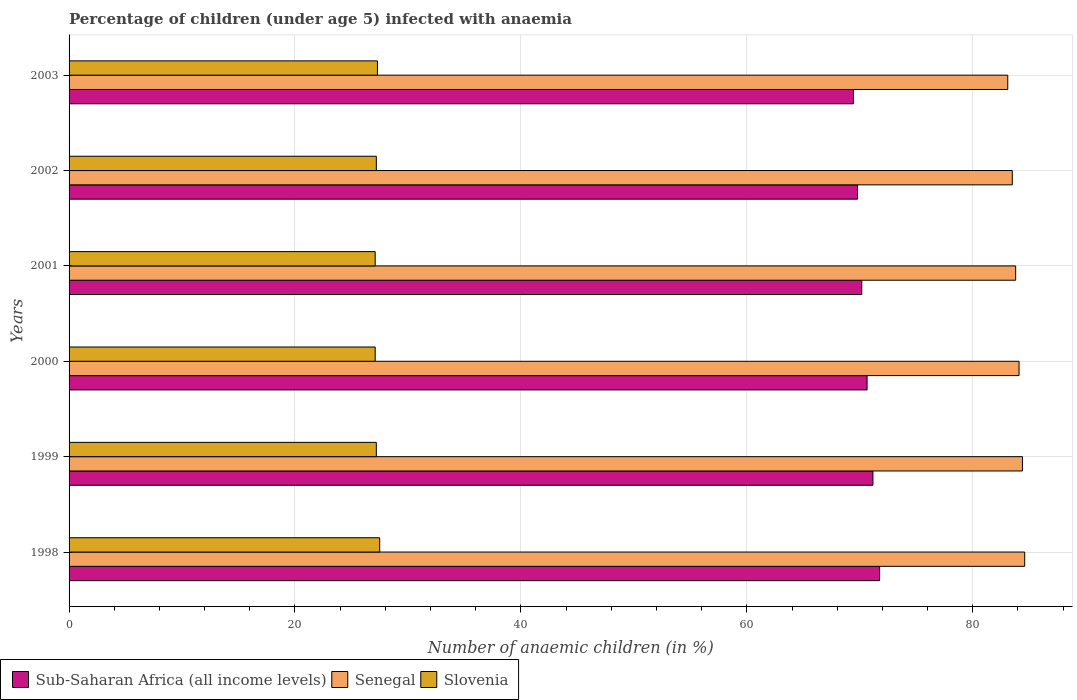Are the number of bars on each tick of the Y-axis equal?
Provide a short and direct response. Yes. How many bars are there on the 3rd tick from the top?
Your answer should be very brief. 3. What is the label of the 2nd group of bars from the top?
Give a very brief answer. 2002. Across all years, what is the maximum percentage of children infected with anaemia in in Senegal?
Offer a very short reply. 84.6. Across all years, what is the minimum percentage of children infected with anaemia in in Slovenia?
Offer a terse response. 27.1. In which year was the percentage of children infected with anaemia in in Slovenia maximum?
Provide a short and direct response. 1998. What is the total percentage of children infected with anaemia in in Senegal in the graph?
Provide a short and direct response. 503.5. What is the difference between the percentage of children infected with anaemia in in Sub-Saharan Africa (all income levels) in 2000 and that in 2001?
Your answer should be very brief. 0.47. What is the difference between the percentage of children infected with anaemia in in Senegal in 2000 and the percentage of children infected with anaemia in in Sub-Saharan Africa (all income levels) in 2003?
Give a very brief answer. 14.66. What is the average percentage of children infected with anaemia in in Slovenia per year?
Ensure brevity in your answer.  27.23. In the year 1999, what is the difference between the percentage of children infected with anaemia in in Senegal and percentage of children infected with anaemia in in Slovenia?
Ensure brevity in your answer.  57.2. What is the ratio of the percentage of children infected with anaemia in in Senegal in 1999 to that in 2001?
Make the answer very short. 1.01. Is the difference between the percentage of children infected with anaemia in in Senegal in 2001 and 2002 greater than the difference between the percentage of children infected with anaemia in in Slovenia in 2001 and 2002?
Offer a terse response. Yes. What is the difference between the highest and the second highest percentage of children infected with anaemia in in Sub-Saharan Africa (all income levels)?
Your answer should be very brief. 0.59. What is the difference between the highest and the lowest percentage of children infected with anaemia in in Senegal?
Make the answer very short. 1.5. In how many years, is the percentage of children infected with anaemia in in Slovenia greater than the average percentage of children infected with anaemia in in Slovenia taken over all years?
Offer a terse response. 2. What does the 1st bar from the top in 2002 represents?
Keep it short and to the point. Slovenia. What does the 3rd bar from the bottom in 1999 represents?
Your answer should be compact. Slovenia. Is it the case that in every year, the sum of the percentage of children infected with anaemia in in Senegal and percentage of children infected with anaemia in in Slovenia is greater than the percentage of children infected with anaemia in in Sub-Saharan Africa (all income levels)?
Offer a terse response. Yes. Are all the bars in the graph horizontal?
Ensure brevity in your answer.  Yes. Are the values on the major ticks of X-axis written in scientific E-notation?
Your answer should be compact. No. Where does the legend appear in the graph?
Give a very brief answer. Bottom left. How many legend labels are there?
Ensure brevity in your answer.  3. How are the legend labels stacked?
Your answer should be compact. Horizontal. What is the title of the graph?
Offer a very short reply. Percentage of children (under age 5) infected with anaemia. Does "Micronesia" appear as one of the legend labels in the graph?
Offer a very short reply. No. What is the label or title of the X-axis?
Keep it short and to the point. Number of anaemic children (in %). What is the label or title of the Y-axis?
Make the answer very short. Years. What is the Number of anaemic children (in %) of Sub-Saharan Africa (all income levels) in 1998?
Your answer should be very brief. 71.75. What is the Number of anaemic children (in %) in Senegal in 1998?
Provide a succinct answer. 84.6. What is the Number of anaemic children (in %) of Slovenia in 1998?
Offer a very short reply. 27.5. What is the Number of anaemic children (in %) in Sub-Saharan Africa (all income levels) in 1999?
Offer a very short reply. 71.16. What is the Number of anaemic children (in %) of Senegal in 1999?
Offer a very short reply. 84.4. What is the Number of anaemic children (in %) in Slovenia in 1999?
Give a very brief answer. 27.2. What is the Number of anaemic children (in %) of Sub-Saharan Africa (all income levels) in 2000?
Offer a terse response. 70.65. What is the Number of anaemic children (in %) of Senegal in 2000?
Your answer should be compact. 84.1. What is the Number of anaemic children (in %) in Slovenia in 2000?
Your response must be concise. 27.1. What is the Number of anaemic children (in %) in Sub-Saharan Africa (all income levels) in 2001?
Offer a very short reply. 70.17. What is the Number of anaemic children (in %) of Senegal in 2001?
Your answer should be compact. 83.8. What is the Number of anaemic children (in %) of Slovenia in 2001?
Provide a succinct answer. 27.1. What is the Number of anaemic children (in %) of Sub-Saharan Africa (all income levels) in 2002?
Provide a succinct answer. 69.8. What is the Number of anaemic children (in %) in Senegal in 2002?
Offer a terse response. 83.5. What is the Number of anaemic children (in %) in Slovenia in 2002?
Give a very brief answer. 27.2. What is the Number of anaemic children (in %) in Sub-Saharan Africa (all income levels) in 2003?
Your answer should be very brief. 69.44. What is the Number of anaemic children (in %) of Senegal in 2003?
Offer a very short reply. 83.1. What is the Number of anaemic children (in %) in Slovenia in 2003?
Offer a very short reply. 27.3. Across all years, what is the maximum Number of anaemic children (in %) in Sub-Saharan Africa (all income levels)?
Your response must be concise. 71.75. Across all years, what is the maximum Number of anaemic children (in %) of Senegal?
Your response must be concise. 84.6. Across all years, what is the maximum Number of anaemic children (in %) of Slovenia?
Offer a very short reply. 27.5. Across all years, what is the minimum Number of anaemic children (in %) of Sub-Saharan Africa (all income levels)?
Your answer should be very brief. 69.44. Across all years, what is the minimum Number of anaemic children (in %) of Senegal?
Keep it short and to the point. 83.1. Across all years, what is the minimum Number of anaemic children (in %) in Slovenia?
Make the answer very short. 27.1. What is the total Number of anaemic children (in %) in Sub-Saharan Africa (all income levels) in the graph?
Offer a terse response. 422.98. What is the total Number of anaemic children (in %) of Senegal in the graph?
Keep it short and to the point. 503.5. What is the total Number of anaemic children (in %) of Slovenia in the graph?
Provide a short and direct response. 163.4. What is the difference between the Number of anaemic children (in %) of Sub-Saharan Africa (all income levels) in 1998 and that in 1999?
Your response must be concise. 0.59. What is the difference between the Number of anaemic children (in %) of Senegal in 1998 and that in 1999?
Ensure brevity in your answer.  0.2. What is the difference between the Number of anaemic children (in %) in Sub-Saharan Africa (all income levels) in 1998 and that in 2000?
Provide a short and direct response. 1.11. What is the difference between the Number of anaemic children (in %) of Senegal in 1998 and that in 2000?
Your response must be concise. 0.5. What is the difference between the Number of anaemic children (in %) in Sub-Saharan Africa (all income levels) in 1998 and that in 2001?
Offer a terse response. 1.58. What is the difference between the Number of anaemic children (in %) in Sub-Saharan Africa (all income levels) in 1998 and that in 2002?
Keep it short and to the point. 1.95. What is the difference between the Number of anaemic children (in %) of Sub-Saharan Africa (all income levels) in 1998 and that in 2003?
Keep it short and to the point. 2.32. What is the difference between the Number of anaemic children (in %) in Slovenia in 1998 and that in 2003?
Your answer should be very brief. 0.2. What is the difference between the Number of anaemic children (in %) of Sub-Saharan Africa (all income levels) in 1999 and that in 2000?
Make the answer very short. 0.52. What is the difference between the Number of anaemic children (in %) of Senegal in 1999 and that in 2000?
Your answer should be compact. 0.3. What is the difference between the Number of anaemic children (in %) of Sub-Saharan Africa (all income levels) in 1999 and that in 2001?
Offer a very short reply. 0.99. What is the difference between the Number of anaemic children (in %) in Sub-Saharan Africa (all income levels) in 1999 and that in 2002?
Provide a succinct answer. 1.36. What is the difference between the Number of anaemic children (in %) of Sub-Saharan Africa (all income levels) in 1999 and that in 2003?
Make the answer very short. 1.72. What is the difference between the Number of anaemic children (in %) of Senegal in 1999 and that in 2003?
Make the answer very short. 1.3. What is the difference between the Number of anaemic children (in %) of Slovenia in 1999 and that in 2003?
Offer a very short reply. -0.1. What is the difference between the Number of anaemic children (in %) in Sub-Saharan Africa (all income levels) in 2000 and that in 2001?
Provide a short and direct response. 0.47. What is the difference between the Number of anaemic children (in %) of Senegal in 2000 and that in 2001?
Your response must be concise. 0.3. What is the difference between the Number of anaemic children (in %) of Slovenia in 2000 and that in 2001?
Give a very brief answer. 0. What is the difference between the Number of anaemic children (in %) in Sub-Saharan Africa (all income levels) in 2000 and that in 2002?
Your response must be concise. 0.84. What is the difference between the Number of anaemic children (in %) in Slovenia in 2000 and that in 2002?
Ensure brevity in your answer.  -0.1. What is the difference between the Number of anaemic children (in %) in Sub-Saharan Africa (all income levels) in 2000 and that in 2003?
Ensure brevity in your answer.  1.21. What is the difference between the Number of anaemic children (in %) in Slovenia in 2000 and that in 2003?
Ensure brevity in your answer.  -0.2. What is the difference between the Number of anaemic children (in %) of Sub-Saharan Africa (all income levels) in 2001 and that in 2002?
Offer a very short reply. 0.37. What is the difference between the Number of anaemic children (in %) of Senegal in 2001 and that in 2002?
Your answer should be very brief. 0.3. What is the difference between the Number of anaemic children (in %) of Slovenia in 2001 and that in 2002?
Give a very brief answer. -0.1. What is the difference between the Number of anaemic children (in %) in Sub-Saharan Africa (all income levels) in 2001 and that in 2003?
Give a very brief answer. 0.73. What is the difference between the Number of anaemic children (in %) in Slovenia in 2001 and that in 2003?
Ensure brevity in your answer.  -0.2. What is the difference between the Number of anaemic children (in %) in Sub-Saharan Africa (all income levels) in 2002 and that in 2003?
Your answer should be compact. 0.36. What is the difference between the Number of anaemic children (in %) in Senegal in 2002 and that in 2003?
Keep it short and to the point. 0.4. What is the difference between the Number of anaemic children (in %) of Sub-Saharan Africa (all income levels) in 1998 and the Number of anaemic children (in %) of Senegal in 1999?
Provide a short and direct response. -12.65. What is the difference between the Number of anaemic children (in %) in Sub-Saharan Africa (all income levels) in 1998 and the Number of anaemic children (in %) in Slovenia in 1999?
Provide a short and direct response. 44.55. What is the difference between the Number of anaemic children (in %) in Senegal in 1998 and the Number of anaemic children (in %) in Slovenia in 1999?
Your answer should be compact. 57.4. What is the difference between the Number of anaemic children (in %) in Sub-Saharan Africa (all income levels) in 1998 and the Number of anaemic children (in %) in Senegal in 2000?
Ensure brevity in your answer.  -12.35. What is the difference between the Number of anaemic children (in %) of Sub-Saharan Africa (all income levels) in 1998 and the Number of anaemic children (in %) of Slovenia in 2000?
Your answer should be compact. 44.65. What is the difference between the Number of anaemic children (in %) in Senegal in 1998 and the Number of anaemic children (in %) in Slovenia in 2000?
Your answer should be compact. 57.5. What is the difference between the Number of anaemic children (in %) of Sub-Saharan Africa (all income levels) in 1998 and the Number of anaemic children (in %) of Senegal in 2001?
Keep it short and to the point. -12.05. What is the difference between the Number of anaemic children (in %) in Sub-Saharan Africa (all income levels) in 1998 and the Number of anaemic children (in %) in Slovenia in 2001?
Keep it short and to the point. 44.65. What is the difference between the Number of anaemic children (in %) of Senegal in 1998 and the Number of anaemic children (in %) of Slovenia in 2001?
Offer a very short reply. 57.5. What is the difference between the Number of anaemic children (in %) in Sub-Saharan Africa (all income levels) in 1998 and the Number of anaemic children (in %) in Senegal in 2002?
Give a very brief answer. -11.75. What is the difference between the Number of anaemic children (in %) in Sub-Saharan Africa (all income levels) in 1998 and the Number of anaemic children (in %) in Slovenia in 2002?
Offer a terse response. 44.55. What is the difference between the Number of anaemic children (in %) of Senegal in 1998 and the Number of anaemic children (in %) of Slovenia in 2002?
Provide a short and direct response. 57.4. What is the difference between the Number of anaemic children (in %) of Sub-Saharan Africa (all income levels) in 1998 and the Number of anaemic children (in %) of Senegal in 2003?
Provide a succinct answer. -11.35. What is the difference between the Number of anaemic children (in %) in Sub-Saharan Africa (all income levels) in 1998 and the Number of anaemic children (in %) in Slovenia in 2003?
Keep it short and to the point. 44.45. What is the difference between the Number of anaemic children (in %) in Senegal in 1998 and the Number of anaemic children (in %) in Slovenia in 2003?
Offer a very short reply. 57.3. What is the difference between the Number of anaemic children (in %) of Sub-Saharan Africa (all income levels) in 1999 and the Number of anaemic children (in %) of Senegal in 2000?
Provide a short and direct response. -12.94. What is the difference between the Number of anaemic children (in %) of Sub-Saharan Africa (all income levels) in 1999 and the Number of anaemic children (in %) of Slovenia in 2000?
Ensure brevity in your answer.  44.06. What is the difference between the Number of anaemic children (in %) of Senegal in 1999 and the Number of anaemic children (in %) of Slovenia in 2000?
Offer a terse response. 57.3. What is the difference between the Number of anaemic children (in %) of Sub-Saharan Africa (all income levels) in 1999 and the Number of anaemic children (in %) of Senegal in 2001?
Your response must be concise. -12.64. What is the difference between the Number of anaemic children (in %) in Sub-Saharan Africa (all income levels) in 1999 and the Number of anaemic children (in %) in Slovenia in 2001?
Your response must be concise. 44.06. What is the difference between the Number of anaemic children (in %) of Senegal in 1999 and the Number of anaemic children (in %) of Slovenia in 2001?
Give a very brief answer. 57.3. What is the difference between the Number of anaemic children (in %) of Sub-Saharan Africa (all income levels) in 1999 and the Number of anaemic children (in %) of Senegal in 2002?
Provide a short and direct response. -12.34. What is the difference between the Number of anaemic children (in %) of Sub-Saharan Africa (all income levels) in 1999 and the Number of anaemic children (in %) of Slovenia in 2002?
Your answer should be compact. 43.96. What is the difference between the Number of anaemic children (in %) in Senegal in 1999 and the Number of anaemic children (in %) in Slovenia in 2002?
Your answer should be very brief. 57.2. What is the difference between the Number of anaemic children (in %) in Sub-Saharan Africa (all income levels) in 1999 and the Number of anaemic children (in %) in Senegal in 2003?
Your response must be concise. -11.94. What is the difference between the Number of anaemic children (in %) of Sub-Saharan Africa (all income levels) in 1999 and the Number of anaemic children (in %) of Slovenia in 2003?
Ensure brevity in your answer.  43.86. What is the difference between the Number of anaemic children (in %) of Senegal in 1999 and the Number of anaemic children (in %) of Slovenia in 2003?
Offer a terse response. 57.1. What is the difference between the Number of anaemic children (in %) of Sub-Saharan Africa (all income levels) in 2000 and the Number of anaemic children (in %) of Senegal in 2001?
Your response must be concise. -13.15. What is the difference between the Number of anaemic children (in %) of Sub-Saharan Africa (all income levels) in 2000 and the Number of anaemic children (in %) of Slovenia in 2001?
Offer a very short reply. 43.55. What is the difference between the Number of anaemic children (in %) in Senegal in 2000 and the Number of anaemic children (in %) in Slovenia in 2001?
Ensure brevity in your answer.  57. What is the difference between the Number of anaemic children (in %) in Sub-Saharan Africa (all income levels) in 2000 and the Number of anaemic children (in %) in Senegal in 2002?
Ensure brevity in your answer.  -12.85. What is the difference between the Number of anaemic children (in %) in Sub-Saharan Africa (all income levels) in 2000 and the Number of anaemic children (in %) in Slovenia in 2002?
Offer a very short reply. 43.45. What is the difference between the Number of anaemic children (in %) in Senegal in 2000 and the Number of anaemic children (in %) in Slovenia in 2002?
Your answer should be compact. 56.9. What is the difference between the Number of anaemic children (in %) of Sub-Saharan Africa (all income levels) in 2000 and the Number of anaemic children (in %) of Senegal in 2003?
Offer a very short reply. -12.45. What is the difference between the Number of anaemic children (in %) of Sub-Saharan Africa (all income levels) in 2000 and the Number of anaemic children (in %) of Slovenia in 2003?
Give a very brief answer. 43.35. What is the difference between the Number of anaemic children (in %) of Senegal in 2000 and the Number of anaemic children (in %) of Slovenia in 2003?
Your answer should be compact. 56.8. What is the difference between the Number of anaemic children (in %) in Sub-Saharan Africa (all income levels) in 2001 and the Number of anaemic children (in %) in Senegal in 2002?
Ensure brevity in your answer.  -13.33. What is the difference between the Number of anaemic children (in %) of Sub-Saharan Africa (all income levels) in 2001 and the Number of anaemic children (in %) of Slovenia in 2002?
Your answer should be compact. 42.97. What is the difference between the Number of anaemic children (in %) in Senegal in 2001 and the Number of anaemic children (in %) in Slovenia in 2002?
Your answer should be compact. 56.6. What is the difference between the Number of anaemic children (in %) in Sub-Saharan Africa (all income levels) in 2001 and the Number of anaemic children (in %) in Senegal in 2003?
Provide a short and direct response. -12.93. What is the difference between the Number of anaemic children (in %) in Sub-Saharan Africa (all income levels) in 2001 and the Number of anaemic children (in %) in Slovenia in 2003?
Your answer should be very brief. 42.87. What is the difference between the Number of anaemic children (in %) of Senegal in 2001 and the Number of anaemic children (in %) of Slovenia in 2003?
Offer a very short reply. 56.5. What is the difference between the Number of anaemic children (in %) in Sub-Saharan Africa (all income levels) in 2002 and the Number of anaemic children (in %) in Senegal in 2003?
Ensure brevity in your answer.  -13.3. What is the difference between the Number of anaemic children (in %) of Sub-Saharan Africa (all income levels) in 2002 and the Number of anaemic children (in %) of Slovenia in 2003?
Make the answer very short. 42.5. What is the difference between the Number of anaemic children (in %) in Senegal in 2002 and the Number of anaemic children (in %) in Slovenia in 2003?
Your answer should be very brief. 56.2. What is the average Number of anaemic children (in %) of Sub-Saharan Africa (all income levels) per year?
Your answer should be compact. 70.5. What is the average Number of anaemic children (in %) in Senegal per year?
Offer a terse response. 83.92. What is the average Number of anaemic children (in %) in Slovenia per year?
Keep it short and to the point. 27.23. In the year 1998, what is the difference between the Number of anaemic children (in %) in Sub-Saharan Africa (all income levels) and Number of anaemic children (in %) in Senegal?
Your answer should be compact. -12.85. In the year 1998, what is the difference between the Number of anaemic children (in %) of Sub-Saharan Africa (all income levels) and Number of anaemic children (in %) of Slovenia?
Offer a very short reply. 44.25. In the year 1998, what is the difference between the Number of anaemic children (in %) in Senegal and Number of anaemic children (in %) in Slovenia?
Give a very brief answer. 57.1. In the year 1999, what is the difference between the Number of anaemic children (in %) of Sub-Saharan Africa (all income levels) and Number of anaemic children (in %) of Senegal?
Your answer should be very brief. -13.24. In the year 1999, what is the difference between the Number of anaemic children (in %) in Sub-Saharan Africa (all income levels) and Number of anaemic children (in %) in Slovenia?
Your answer should be very brief. 43.96. In the year 1999, what is the difference between the Number of anaemic children (in %) of Senegal and Number of anaemic children (in %) of Slovenia?
Provide a short and direct response. 57.2. In the year 2000, what is the difference between the Number of anaemic children (in %) in Sub-Saharan Africa (all income levels) and Number of anaemic children (in %) in Senegal?
Your answer should be compact. -13.45. In the year 2000, what is the difference between the Number of anaemic children (in %) in Sub-Saharan Africa (all income levels) and Number of anaemic children (in %) in Slovenia?
Your answer should be compact. 43.55. In the year 2001, what is the difference between the Number of anaemic children (in %) of Sub-Saharan Africa (all income levels) and Number of anaemic children (in %) of Senegal?
Your response must be concise. -13.63. In the year 2001, what is the difference between the Number of anaemic children (in %) of Sub-Saharan Africa (all income levels) and Number of anaemic children (in %) of Slovenia?
Your response must be concise. 43.07. In the year 2001, what is the difference between the Number of anaemic children (in %) in Senegal and Number of anaemic children (in %) in Slovenia?
Provide a succinct answer. 56.7. In the year 2002, what is the difference between the Number of anaemic children (in %) of Sub-Saharan Africa (all income levels) and Number of anaemic children (in %) of Senegal?
Make the answer very short. -13.7. In the year 2002, what is the difference between the Number of anaemic children (in %) in Sub-Saharan Africa (all income levels) and Number of anaemic children (in %) in Slovenia?
Offer a terse response. 42.6. In the year 2002, what is the difference between the Number of anaemic children (in %) of Senegal and Number of anaemic children (in %) of Slovenia?
Make the answer very short. 56.3. In the year 2003, what is the difference between the Number of anaemic children (in %) of Sub-Saharan Africa (all income levels) and Number of anaemic children (in %) of Senegal?
Provide a succinct answer. -13.66. In the year 2003, what is the difference between the Number of anaemic children (in %) in Sub-Saharan Africa (all income levels) and Number of anaemic children (in %) in Slovenia?
Provide a short and direct response. 42.14. In the year 2003, what is the difference between the Number of anaemic children (in %) in Senegal and Number of anaemic children (in %) in Slovenia?
Provide a short and direct response. 55.8. What is the ratio of the Number of anaemic children (in %) of Sub-Saharan Africa (all income levels) in 1998 to that in 1999?
Keep it short and to the point. 1.01. What is the ratio of the Number of anaemic children (in %) of Senegal in 1998 to that in 1999?
Ensure brevity in your answer.  1. What is the ratio of the Number of anaemic children (in %) of Slovenia in 1998 to that in 1999?
Your response must be concise. 1.01. What is the ratio of the Number of anaemic children (in %) in Sub-Saharan Africa (all income levels) in 1998 to that in 2000?
Make the answer very short. 1.02. What is the ratio of the Number of anaemic children (in %) of Senegal in 1998 to that in 2000?
Your answer should be very brief. 1.01. What is the ratio of the Number of anaemic children (in %) of Slovenia in 1998 to that in 2000?
Offer a very short reply. 1.01. What is the ratio of the Number of anaemic children (in %) of Sub-Saharan Africa (all income levels) in 1998 to that in 2001?
Keep it short and to the point. 1.02. What is the ratio of the Number of anaemic children (in %) of Senegal in 1998 to that in 2001?
Make the answer very short. 1.01. What is the ratio of the Number of anaemic children (in %) in Slovenia in 1998 to that in 2001?
Your response must be concise. 1.01. What is the ratio of the Number of anaemic children (in %) of Sub-Saharan Africa (all income levels) in 1998 to that in 2002?
Keep it short and to the point. 1.03. What is the ratio of the Number of anaemic children (in %) of Senegal in 1998 to that in 2002?
Provide a succinct answer. 1.01. What is the ratio of the Number of anaemic children (in %) of Sub-Saharan Africa (all income levels) in 1998 to that in 2003?
Your answer should be very brief. 1.03. What is the ratio of the Number of anaemic children (in %) in Senegal in 1998 to that in 2003?
Provide a short and direct response. 1.02. What is the ratio of the Number of anaemic children (in %) in Slovenia in 1998 to that in 2003?
Offer a terse response. 1.01. What is the ratio of the Number of anaemic children (in %) of Sub-Saharan Africa (all income levels) in 1999 to that in 2000?
Your answer should be compact. 1.01. What is the ratio of the Number of anaemic children (in %) of Sub-Saharan Africa (all income levels) in 1999 to that in 2001?
Offer a very short reply. 1.01. What is the ratio of the Number of anaemic children (in %) in Slovenia in 1999 to that in 2001?
Your answer should be very brief. 1. What is the ratio of the Number of anaemic children (in %) in Sub-Saharan Africa (all income levels) in 1999 to that in 2002?
Make the answer very short. 1.02. What is the ratio of the Number of anaemic children (in %) in Senegal in 1999 to that in 2002?
Give a very brief answer. 1.01. What is the ratio of the Number of anaemic children (in %) of Slovenia in 1999 to that in 2002?
Give a very brief answer. 1. What is the ratio of the Number of anaemic children (in %) in Sub-Saharan Africa (all income levels) in 1999 to that in 2003?
Your answer should be compact. 1.02. What is the ratio of the Number of anaemic children (in %) of Senegal in 1999 to that in 2003?
Offer a very short reply. 1.02. What is the ratio of the Number of anaemic children (in %) of Slovenia in 1999 to that in 2003?
Provide a succinct answer. 1. What is the ratio of the Number of anaemic children (in %) in Slovenia in 2000 to that in 2001?
Keep it short and to the point. 1. What is the ratio of the Number of anaemic children (in %) in Sub-Saharan Africa (all income levels) in 2000 to that in 2002?
Provide a short and direct response. 1.01. What is the ratio of the Number of anaemic children (in %) of Sub-Saharan Africa (all income levels) in 2000 to that in 2003?
Offer a terse response. 1.02. What is the ratio of the Number of anaemic children (in %) of Senegal in 2000 to that in 2003?
Offer a terse response. 1.01. What is the ratio of the Number of anaemic children (in %) in Slovenia in 2000 to that in 2003?
Ensure brevity in your answer.  0.99. What is the ratio of the Number of anaemic children (in %) in Sub-Saharan Africa (all income levels) in 2001 to that in 2002?
Give a very brief answer. 1.01. What is the ratio of the Number of anaemic children (in %) of Senegal in 2001 to that in 2002?
Provide a short and direct response. 1. What is the ratio of the Number of anaemic children (in %) of Sub-Saharan Africa (all income levels) in 2001 to that in 2003?
Offer a terse response. 1.01. What is the ratio of the Number of anaemic children (in %) in Senegal in 2001 to that in 2003?
Ensure brevity in your answer.  1.01. What is the ratio of the Number of anaemic children (in %) in Slovenia in 2001 to that in 2003?
Provide a short and direct response. 0.99. What is the ratio of the Number of anaemic children (in %) of Sub-Saharan Africa (all income levels) in 2002 to that in 2003?
Give a very brief answer. 1.01. What is the ratio of the Number of anaemic children (in %) of Senegal in 2002 to that in 2003?
Provide a short and direct response. 1. What is the ratio of the Number of anaemic children (in %) in Slovenia in 2002 to that in 2003?
Your response must be concise. 1. What is the difference between the highest and the second highest Number of anaemic children (in %) in Sub-Saharan Africa (all income levels)?
Offer a very short reply. 0.59. What is the difference between the highest and the lowest Number of anaemic children (in %) in Sub-Saharan Africa (all income levels)?
Your response must be concise. 2.32. What is the difference between the highest and the lowest Number of anaemic children (in %) in Senegal?
Offer a terse response. 1.5. What is the difference between the highest and the lowest Number of anaemic children (in %) of Slovenia?
Offer a very short reply. 0.4. 